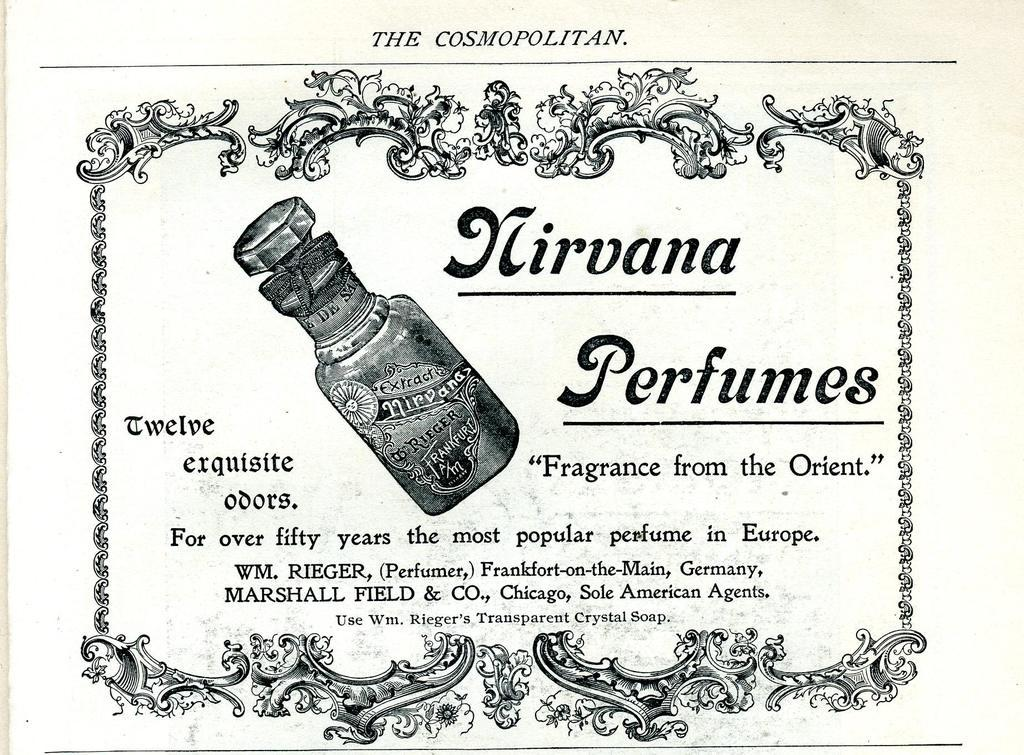Provide a one-sentence caption for the provided image. Nirvana Perfumes Fragrance from the Orient from the Cosmopolitan. 